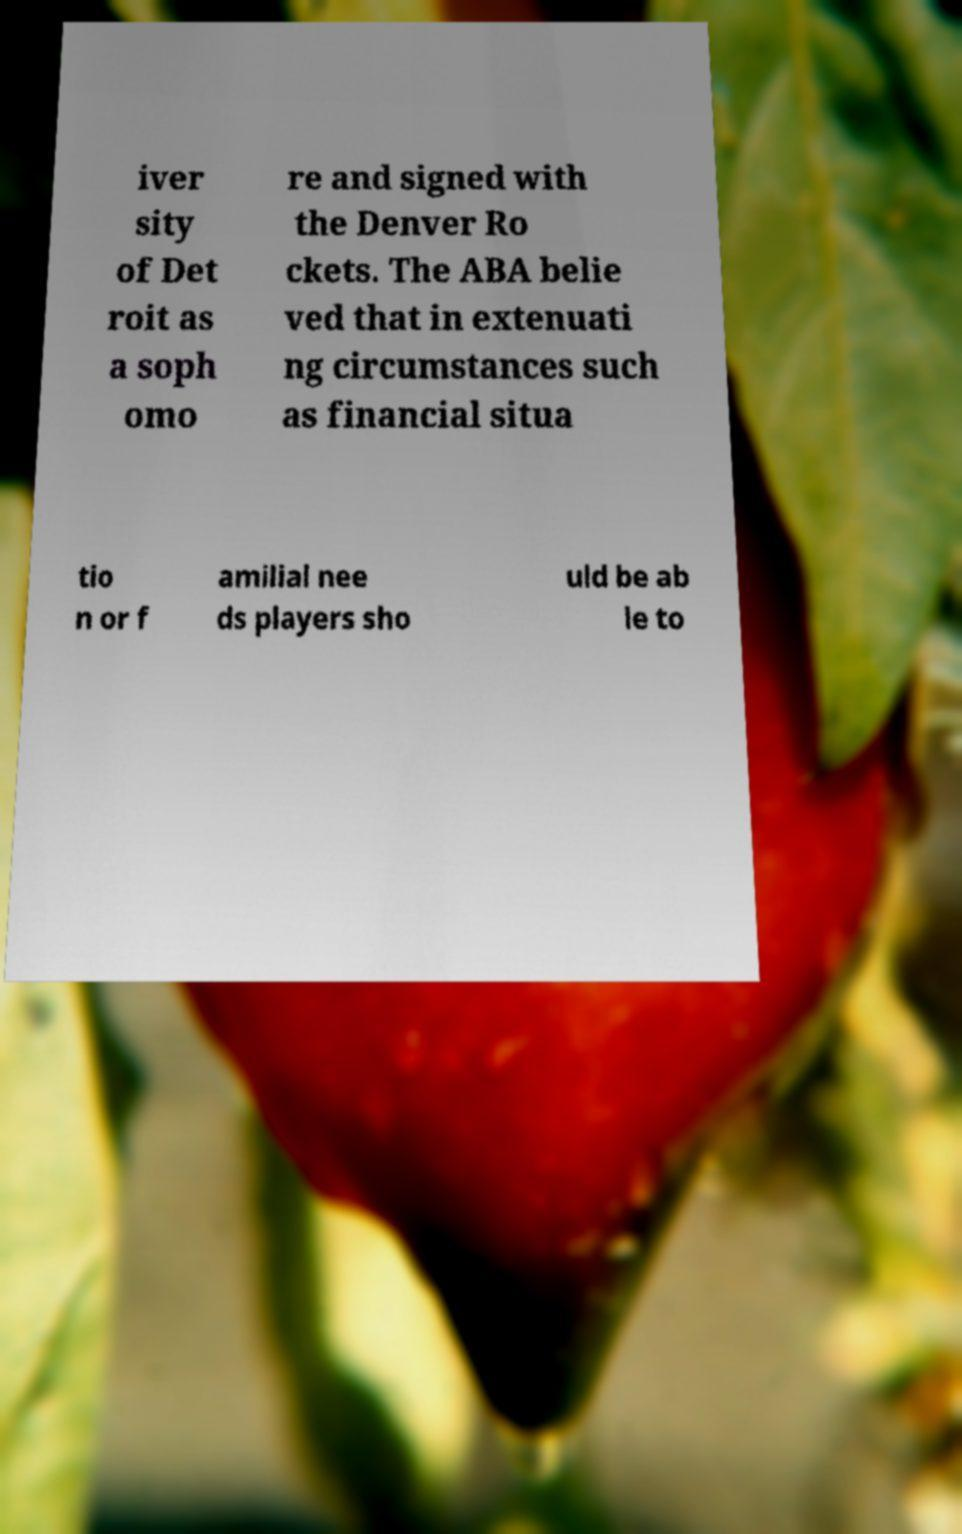Please identify and transcribe the text found in this image. iver sity of Det roit as a soph omo re and signed with the Denver Ro ckets. The ABA belie ved that in extenuati ng circumstances such as financial situa tio n or f amilial nee ds players sho uld be ab le to 